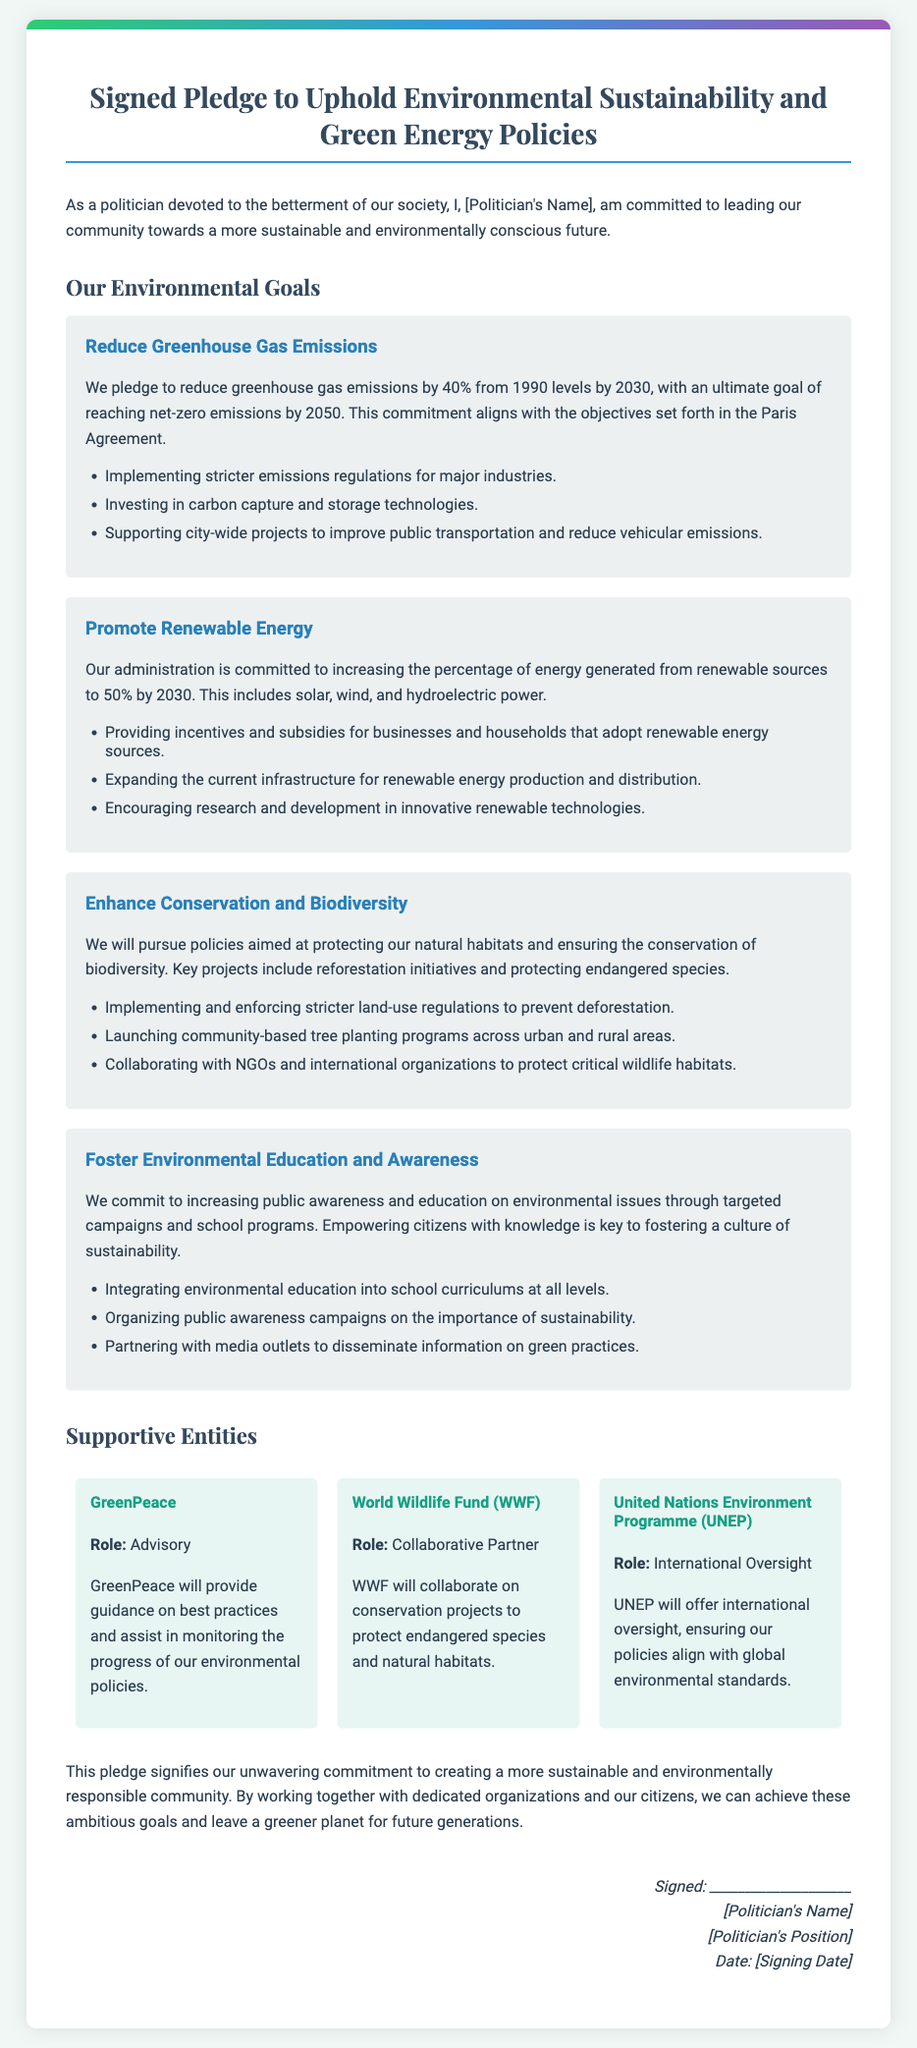What is the emission reduction target by 2030? The document states a pledge to reduce greenhouse gas emissions by 40% from 1990 levels by 2030.
Answer: 40% Who is providing oversight for the environmental policies? The United Nations Environment Programme (UNEP) is mentioned as providing international oversight.
Answer: UNEP What is the ultimate goal for net-zero emissions? The document indicates the ultimate goal of reaching net-zero emissions by 2050.
Answer: 2050 Which organization will assist in monitoring progress? The document lists GreenPeace as providing guidance and assisting in monitoring the progress of environmental policies.
Answer: GreenPeace What percentage of energy is targeted to come from renewable sources by 2030? The commitment is to increase the percentage of energy generated from renewable sources to 50% by 2030.
Answer: 50% What type of regulations are being implemented for major industries? The document mentions implementing stricter emissions regulations for major industries.
Answer: Stricter emissions regulations What public engagement activity is planned to boost environmental awareness? The document states that organizing public awareness campaigns on the importance of sustainability is planned.
Answer: Public awareness campaigns What is the role of the World Wildlife Fund (WWF)? WWF's role is mentioned as a collaborative partner for conservation projects.
Answer: Collaborative Partner 